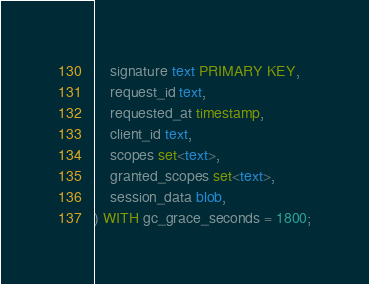Convert code to text. <code><loc_0><loc_0><loc_500><loc_500><_SQL_>    signature text PRIMARY KEY,
    request_id text,
    requested_at timestamp,
    client_id text,
    scopes set<text>,
    granted_scopes set<text>,
    session_data blob,
) WITH gc_grace_seconds = 1800;</code> 